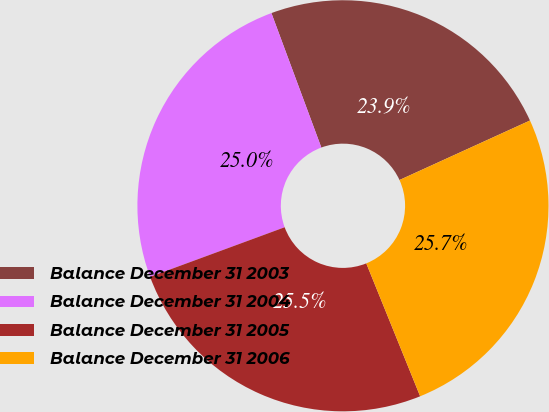<chart> <loc_0><loc_0><loc_500><loc_500><pie_chart><fcel>Balance December 31 2003<fcel>Balance December 31 2004<fcel>Balance December 31 2005<fcel>Balance December 31 2006<nl><fcel>23.85%<fcel>24.96%<fcel>25.51%<fcel>25.68%<nl></chart> 